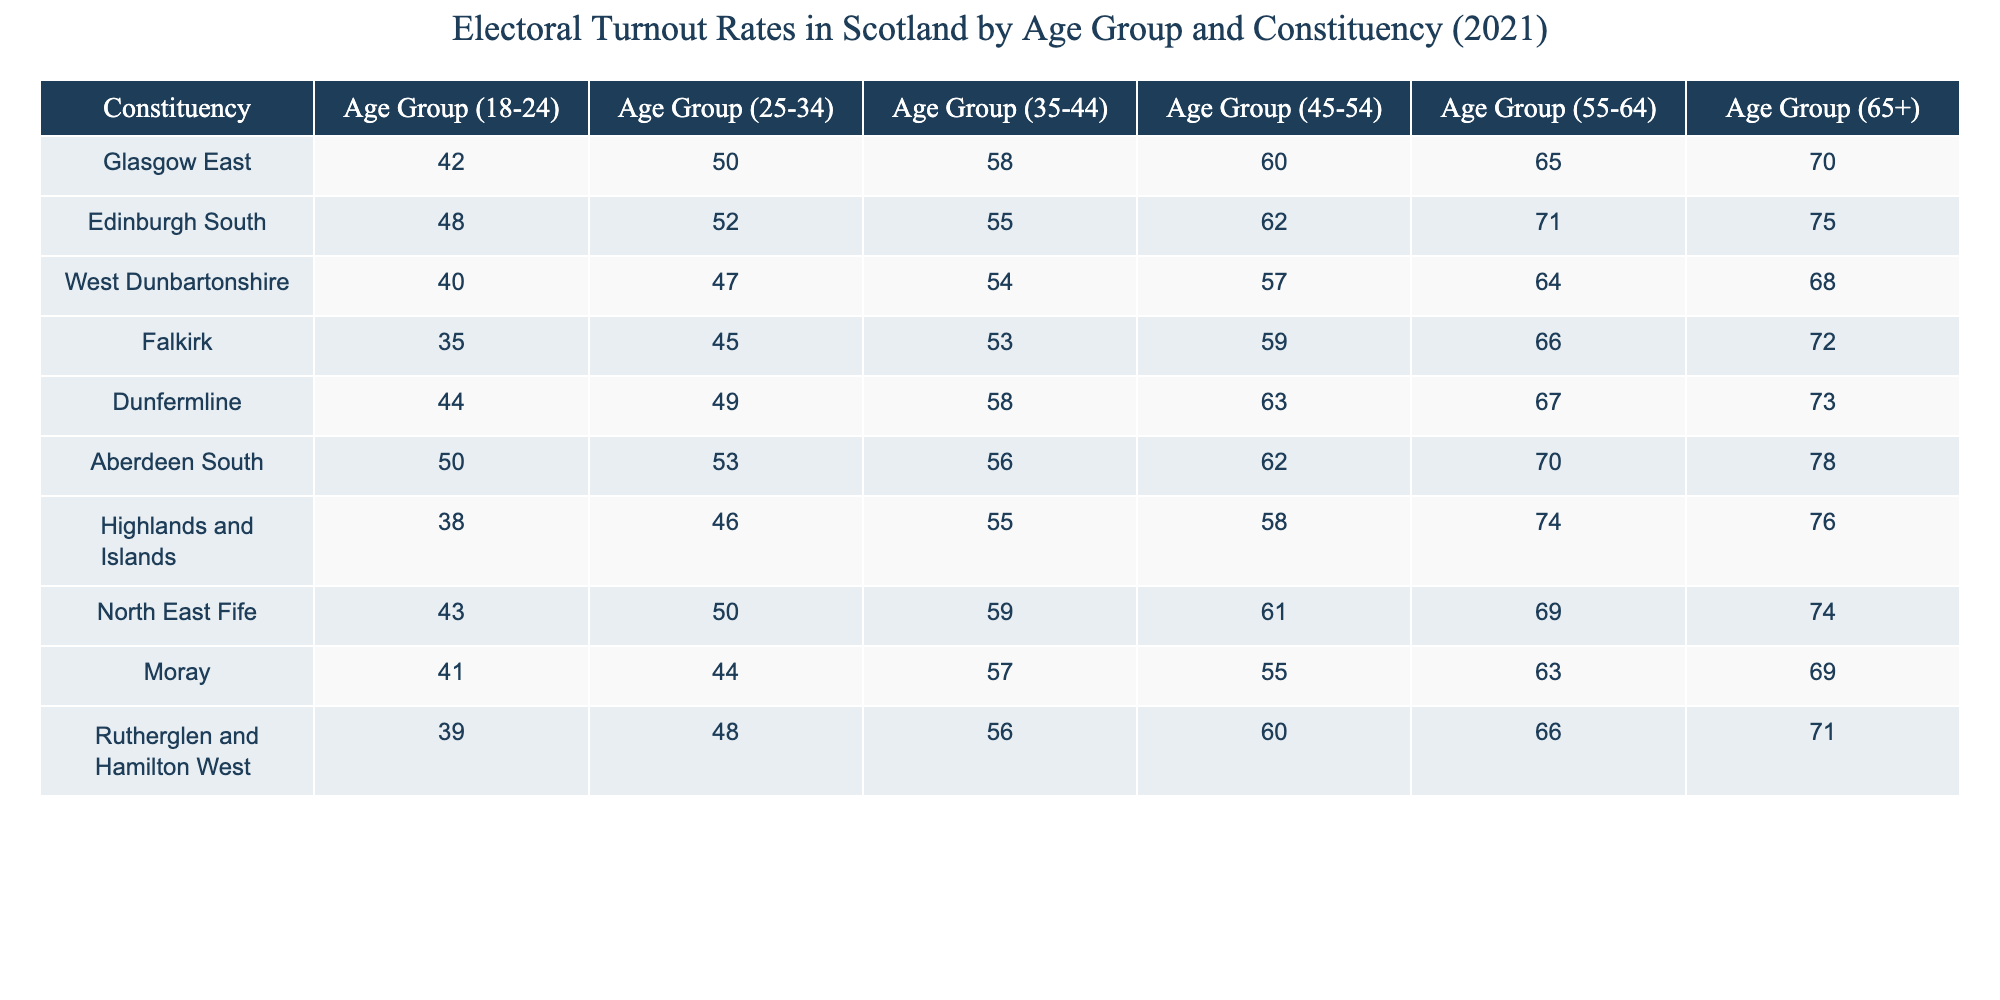What is the turnout rate for the 18-24 age group in Glasgow East? The table lists the turnout rates for different age groups in each constituency. For Glasgow East, the value under the 18-24 age group is 42.
Answer: 42 Which constituency has the highest turnout rate for the 65+ age group? By checking the 65+ age column, we see that Aberdeen South has the highest value of 78 among all constituencies.
Answer: 78 What is the average turnout rate for the 35-44 age group across all constituencies? To find the average for the 35-44 age group, we sum the values: (58 + 55 + 54 + 53 + 58 + 56 + 55 + 59 + 57 + 56) =  551. There are 10 constituencies, so the average is 551/10 = 55.1.
Answer: 55.1 Did any constituency show a turnout rate of over 70 for the 55-64 age group? By looking at the 55-64 age column, we see that both Aberdeen South (70) and Dunfermline (67) are mentioned, but none is over 70, so the answer is no.
Answer: No Which age group had the lowest turnout rate in Falkirk? For Falkirk, the age group values are: 35 for 18-24, 45 for 25-34, 53 for 35-44, 59 for 45-54, 66 for 55-64, and 72 for 65+. The lowest value is 35 for the 18-24 age group.
Answer: 18-24 